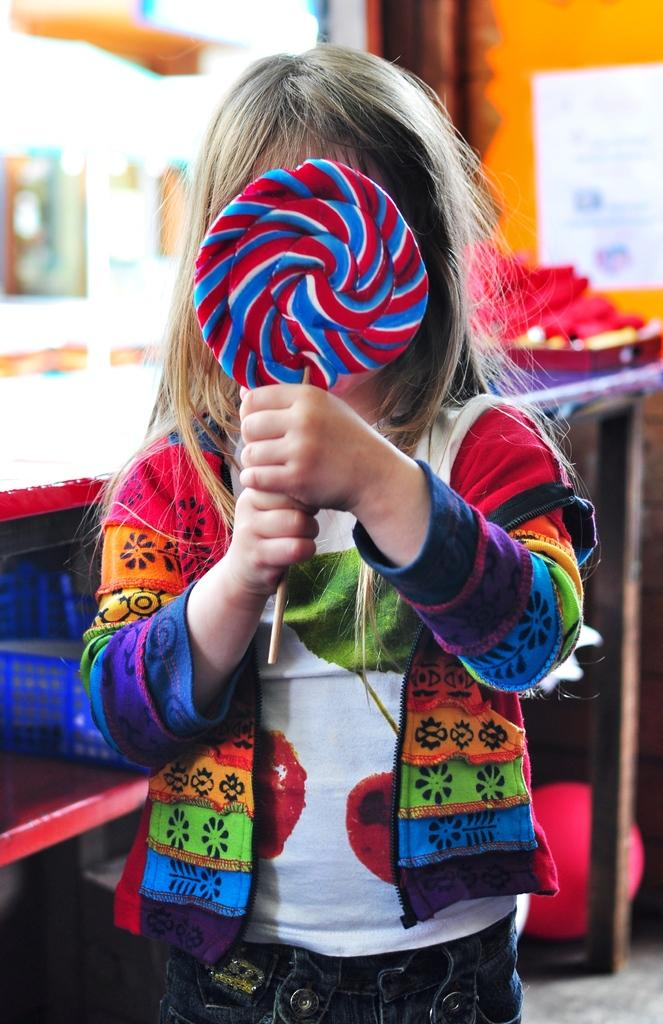What is the main subject of the image? The main subject of the image is a kid standing. What is the kid holding in the image? The kid is holding a lollipop. Can you describe the object next to the kid? There is a basket on an object that looks like a rock. How would you describe the background of the image? The background of the image is blurry. How long does it take for the patch of grass to grow in the image? There is no patch of grass visible in the image, so it's not possible to determine how long it takes for it to grow. 